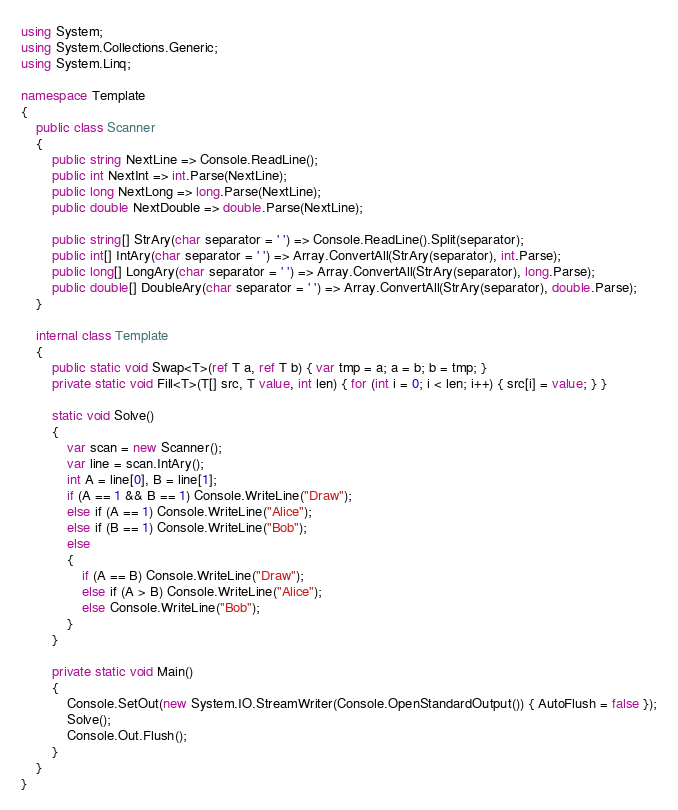Convert code to text. <code><loc_0><loc_0><loc_500><loc_500><_C#_>using System;
using System.Collections.Generic;
using System.Linq;
 
namespace Template
{
    public class Scanner
    {
        public string NextLine => Console.ReadLine();
        public int NextInt => int.Parse(NextLine);
        public long NextLong => long.Parse(NextLine);
        public double NextDouble => double.Parse(NextLine);
 
        public string[] StrAry(char separator = ' ') => Console.ReadLine().Split(separator);
        public int[] IntAry(char separator = ' ') => Array.ConvertAll(StrAry(separator), int.Parse);
        public long[] LongAry(char separator = ' ') => Array.ConvertAll(StrAry(separator), long.Parse);
        public double[] DoubleAry(char separator = ' ') => Array.ConvertAll(StrAry(separator), double.Parse);
    }
 
    internal class Template
    {
        public static void Swap<T>(ref T a, ref T b) { var tmp = a; a = b; b = tmp; }
        private static void Fill<T>(T[] src, T value, int len) { for (int i = 0; i < len; i++) { src[i] = value; } }
 
        static void Solve() 
        {
            var scan = new Scanner();
            var line = scan.IntAry();
            int A = line[0], B = line[1];
            if (A == 1 && B == 1) Console.WriteLine("Draw");
            else if (A == 1) Console.WriteLine("Alice");
            else if (B == 1) Console.WriteLine("Bob");
            else
            {
                if (A == B) Console.WriteLine("Draw");
                else if (A > B) Console.WriteLine("Alice");
                else Console.WriteLine("Bob");
            }
        }
 
        private static void Main()
        {
            Console.SetOut(new System.IO.StreamWriter(Console.OpenStandardOutput()) { AutoFlush = false });
            Solve();
            Console.Out.Flush();
        }
    }
}
</code> 